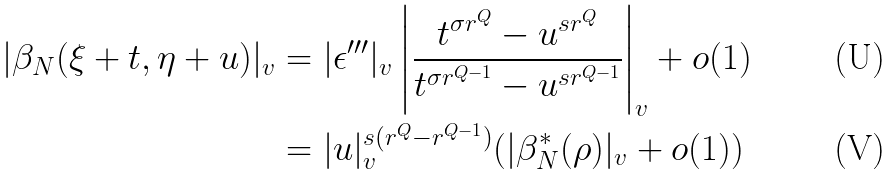Convert formula to latex. <formula><loc_0><loc_0><loc_500><loc_500>| \beta _ { N } ( \xi + t , \eta + u ) | _ { v } & = | \epsilon ^ { \prime \prime \prime } | _ { v } \left | \frac { t ^ { \sigma r ^ { Q } } - u ^ { s r ^ { Q } } } { t ^ { \sigma r ^ { Q - 1 } } - u ^ { s r ^ { Q - 1 } } } \right | _ { v } + o ( 1 ) \\ & = | u | _ { v } ^ { s ( r ^ { Q } - r ^ { Q - 1 } ) } ( | \beta _ { N } ^ { * } ( \rho ) | _ { v } + o ( 1 ) )</formula> 